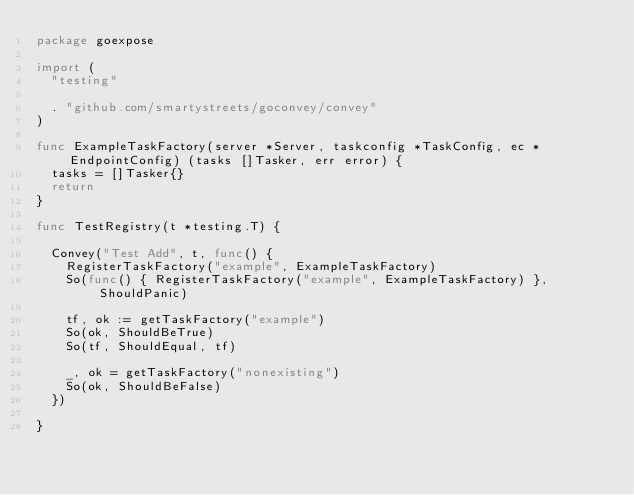Convert code to text. <code><loc_0><loc_0><loc_500><loc_500><_Go_>package goexpose

import (
	"testing"

	. "github.com/smartystreets/goconvey/convey"
)

func ExampleTaskFactory(server *Server, taskconfig *TaskConfig, ec *EndpointConfig) (tasks []Tasker, err error) {
	tasks = []Tasker{}
	return
}

func TestRegistry(t *testing.T) {

	Convey("Test Add", t, func() {
		RegisterTaskFactory("example", ExampleTaskFactory)
		So(func() { RegisterTaskFactory("example", ExampleTaskFactory) }, ShouldPanic)

		tf, ok := getTaskFactory("example")
		So(ok, ShouldBeTrue)
		So(tf, ShouldEqual, tf)

		_, ok = getTaskFactory("nonexisting")
		So(ok, ShouldBeFalse)
	})

}
</code> 